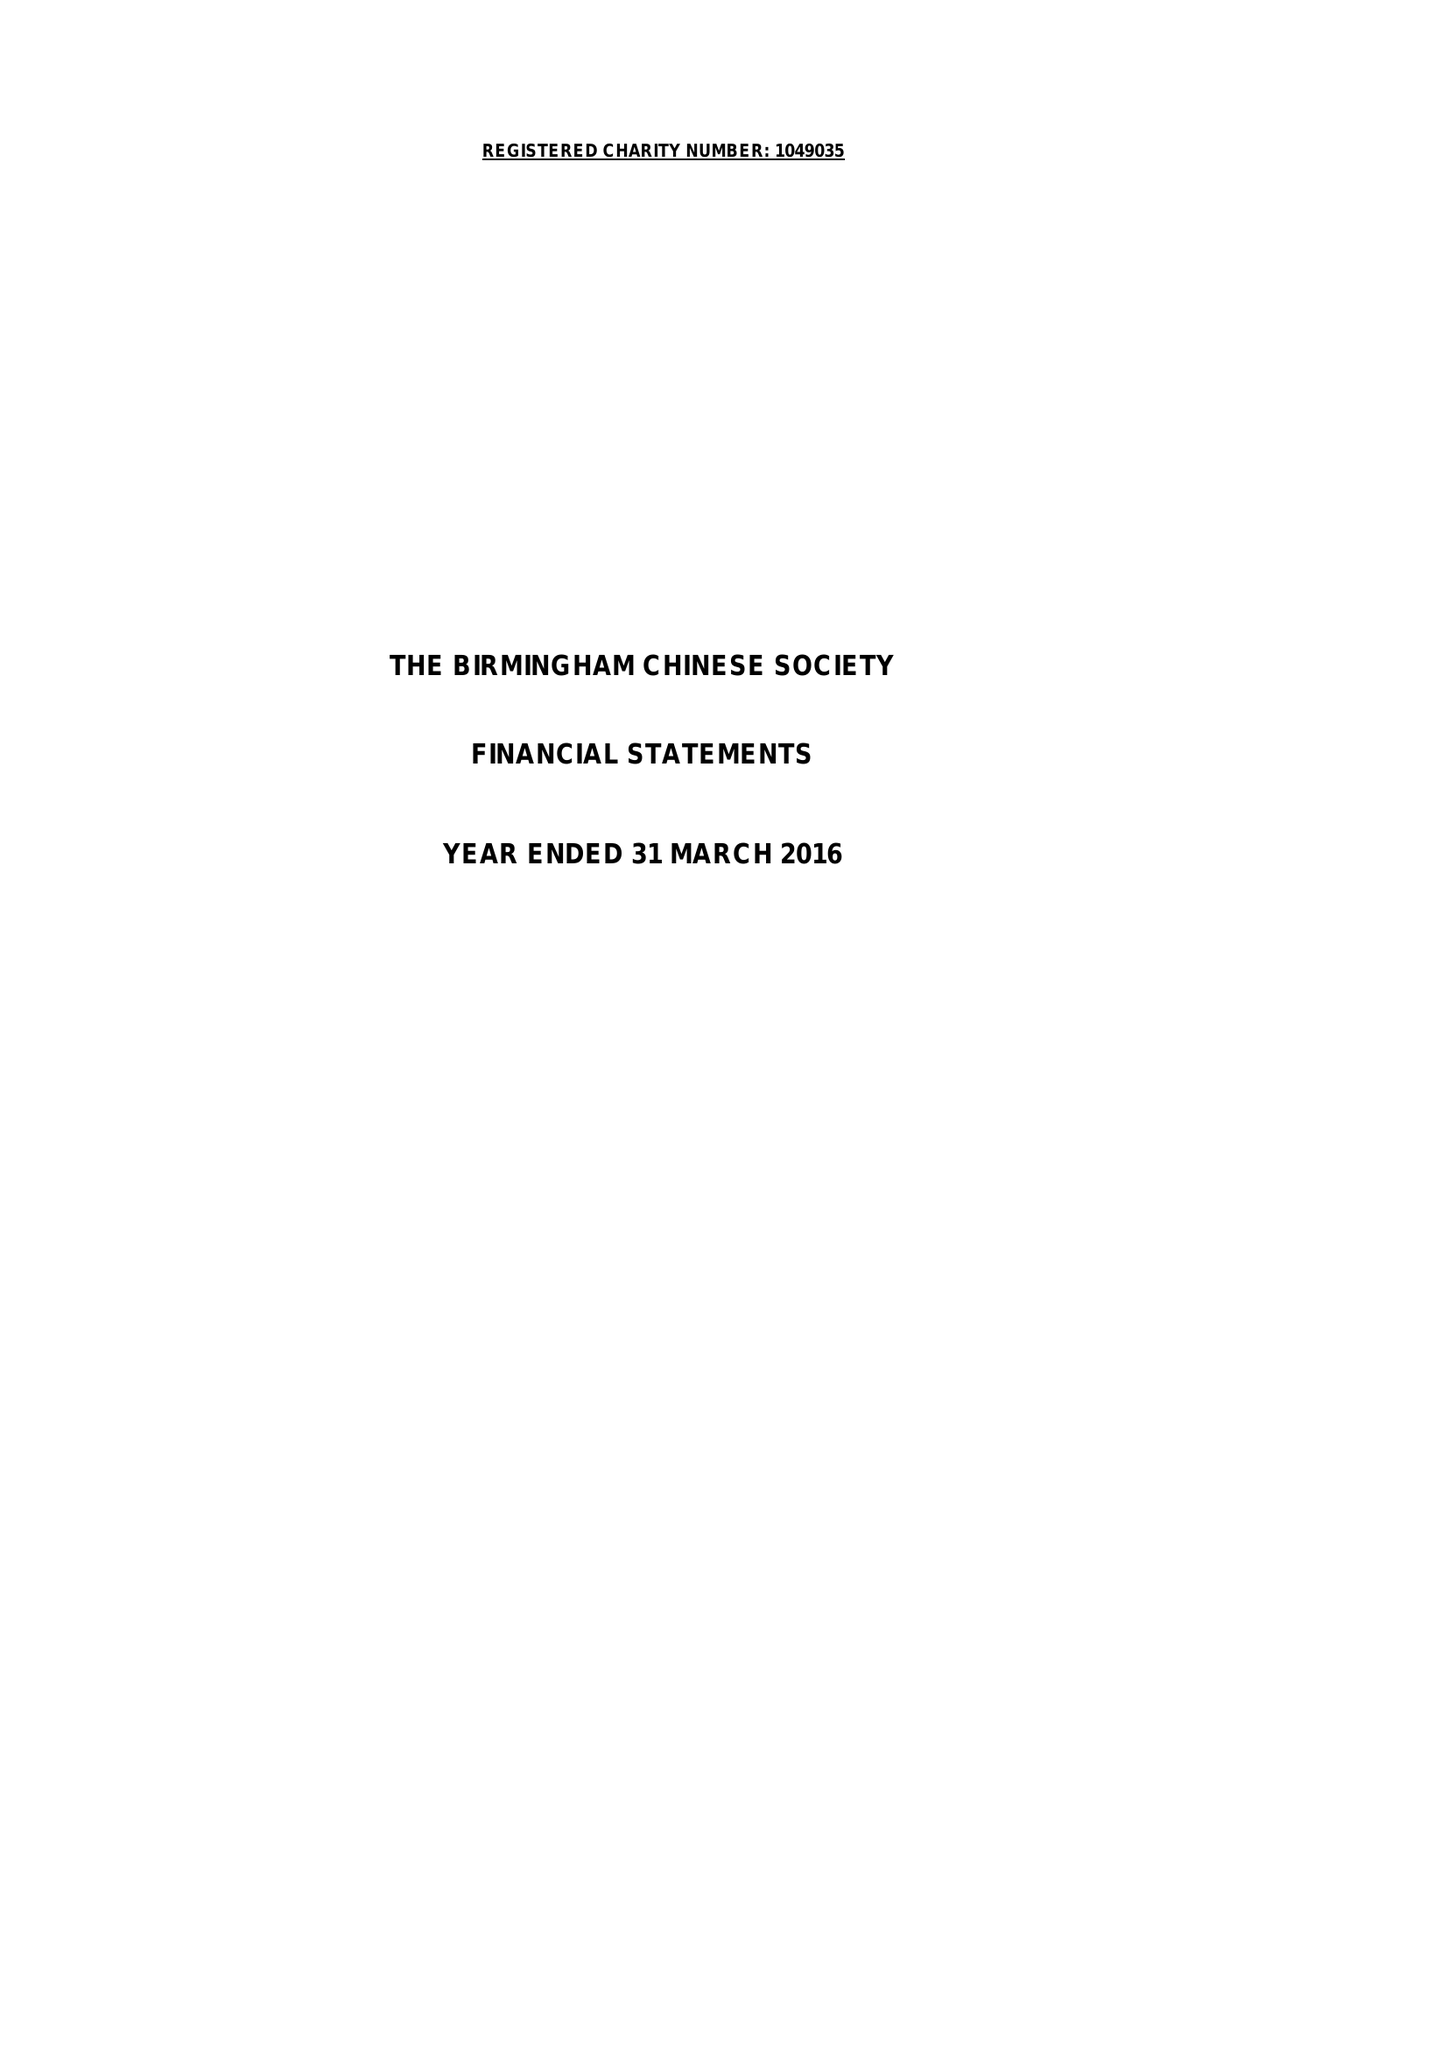What is the value for the report_date?
Answer the question using a single word or phrase. 2016-03-31 